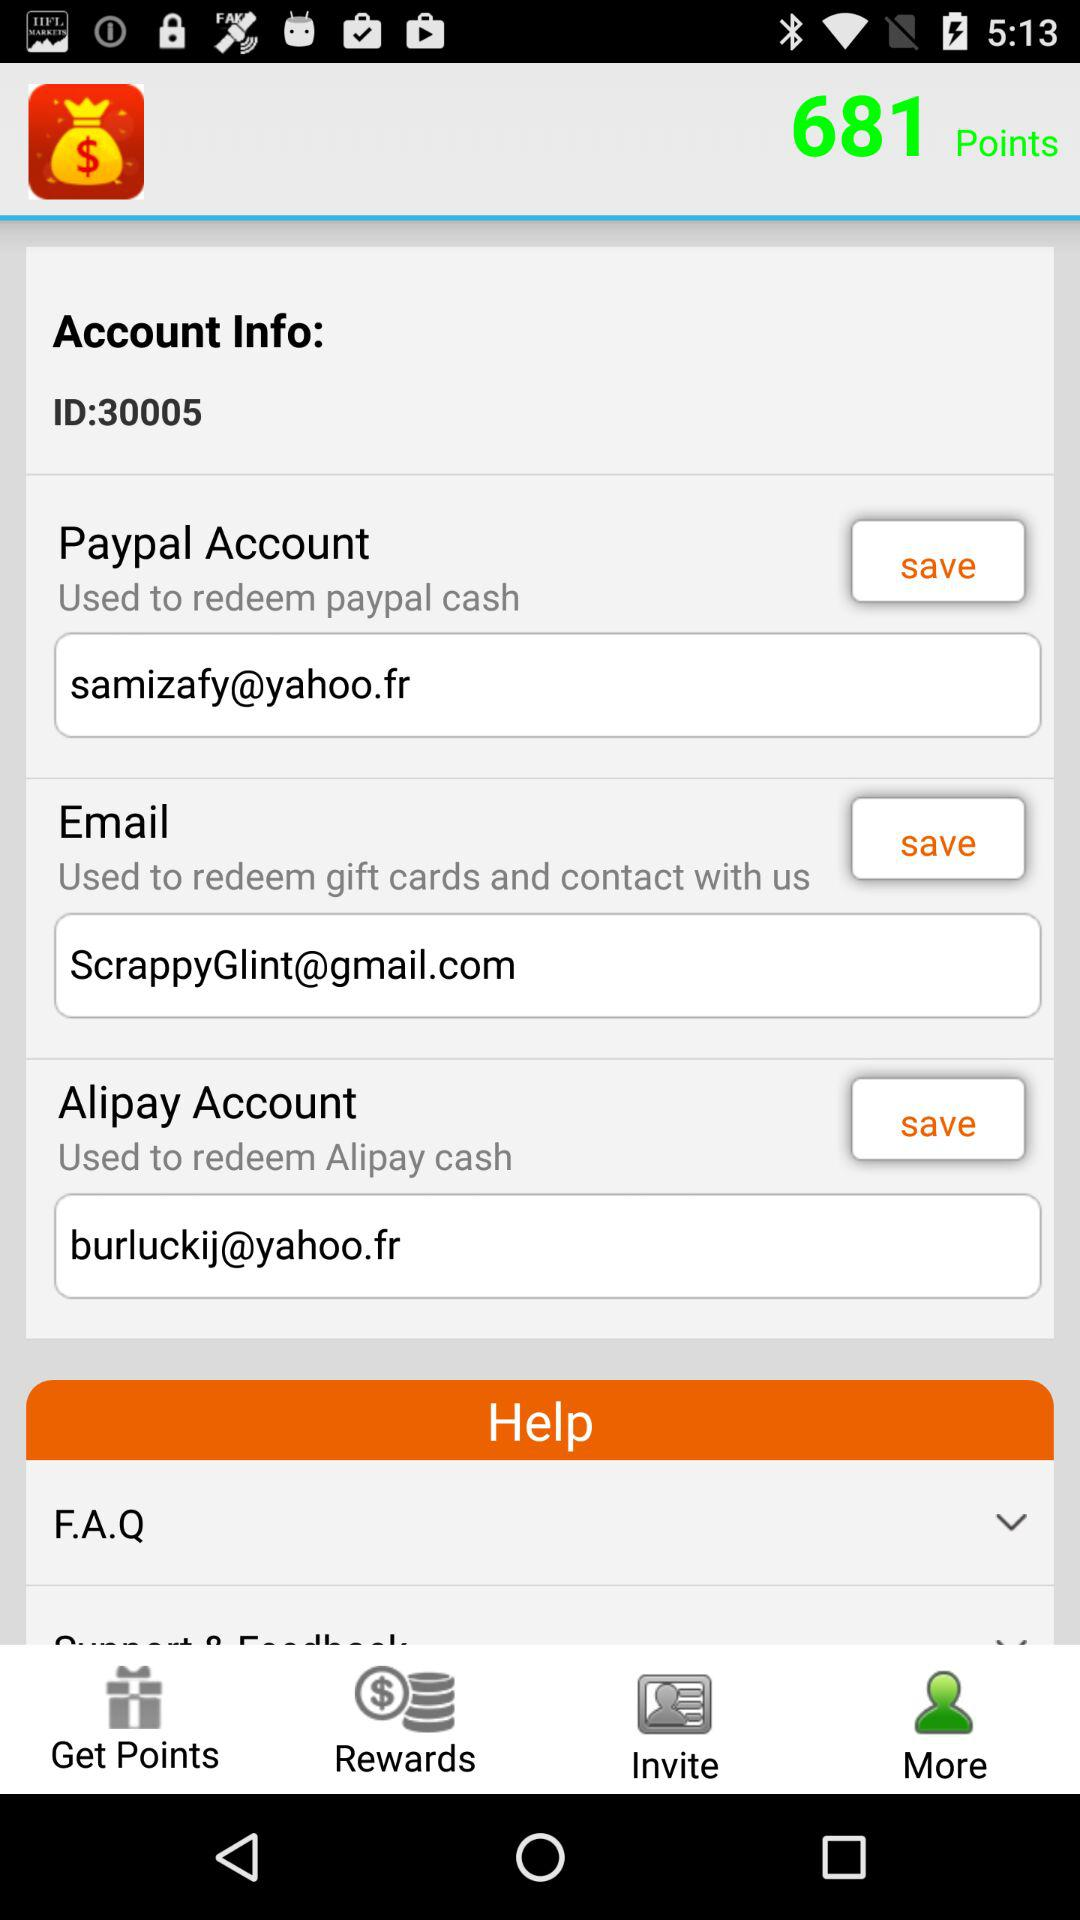How many points are there? There are 681 points. 